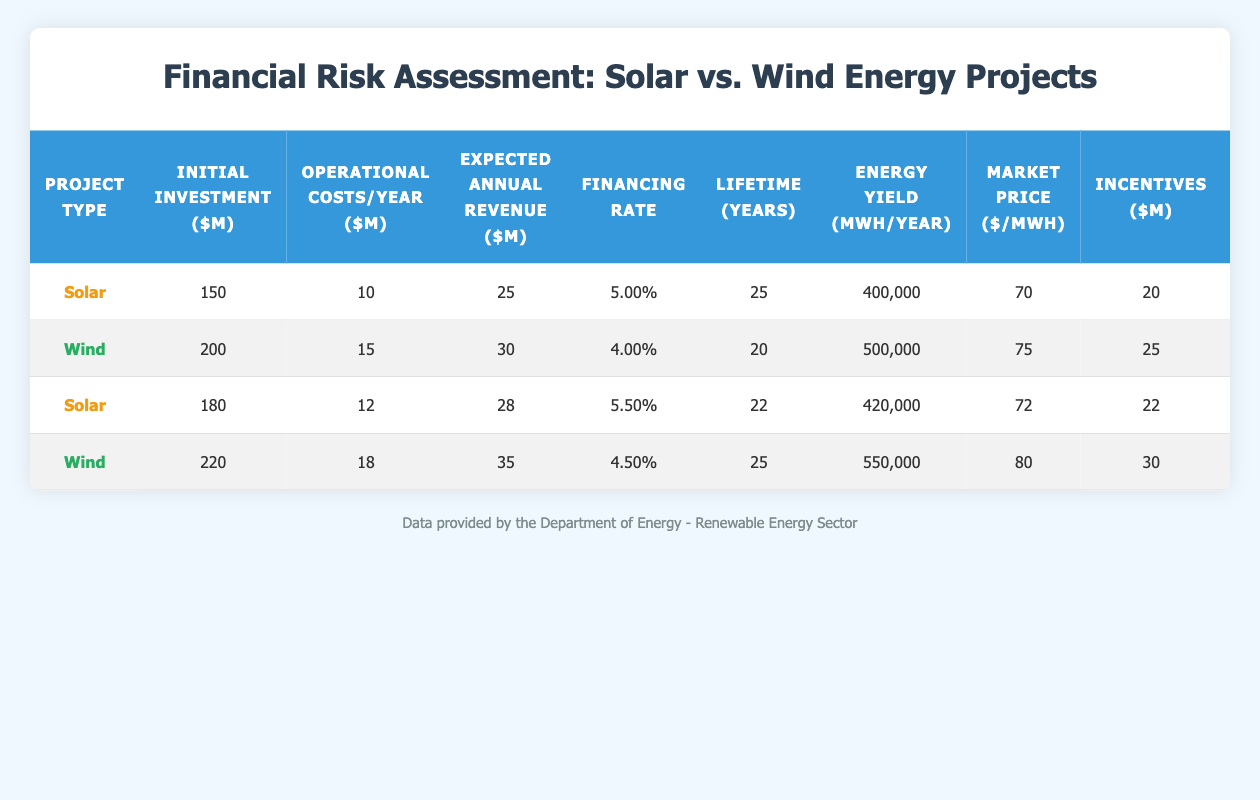What is the initial investment for Wind energy projects? Referring to the table under the row for Wind energy, the initial investment amount is found to be 200 million for the first project and 220 million for the second project.
Answer: 200 million (for the first project), 220 million (for the second project) What are the expected annual revenues for Solar projects? In the table, Solar projects show expected annual revenues of 25 million and 28 million for the first and second Solar projects respectively.
Answer: 25 million (for the first project), 28 million (for the second project) Which project type has a higher default probability? Compare the default probabilities from the table; Solar projects show probabilities of 0.02 and 0.015 while Wind projects show 0.01 and 0.012. Wind projects have lower default probabilities across both projects.
Answer: Wind energy projects have a higher default probability What is the average operational cost per year for Wind projects? The operational costs for Wind projects are 15 million and 18 million. The average is calculated as (15 + 18) / 2 = 16.5 million.
Answer: 16.5 million Which energy type produces a higher energy yield per year? Looking at the energy yield for Solar projects (400,000 and 420,000 MWh) and Wind projects (500,000 and 550,000 MWh), Wind projects have higher yields: 500,000 and 550,000 compared to Solar's 400,000 and 420,000.
Answer: Wind energy projects What is the total amount of incentives for Solar projects combined? The table shows the incentives for Solar projects as 20 million and 22 million. Adding these amounts gives 20 + 22 = 42 million.
Answer: 42 million Is the project completion time for Wind energy shorter than that for Solar energy? From the table, Solar projects have completion times of 1.5 and 1.8 years, while Wind projects have completion times of 2 and 2.5 years; therefore, Wind has a longer completion time than Solar.
Answer: No What is the difference in the expected annual revenue between the highest Solar revenue and the highest Wind revenue? The highest expected annual revenue for Solar is 28 million, and for Wind it is 35 million. The difference is calculated as 35 - 28 = 7 million.
Answer: 7 million Which project has both a higher initial investment and expected annual revenue? Comparing the Solar projects with initial investments of 150 and 180 million against Wind investments of 200 and 220 million, while expected revenues for Solar are 25 and 28 million and for Wind are 30 and 35 million, Wind projects exceed both criteria (220M and 35M).
Answer: Wind projects 